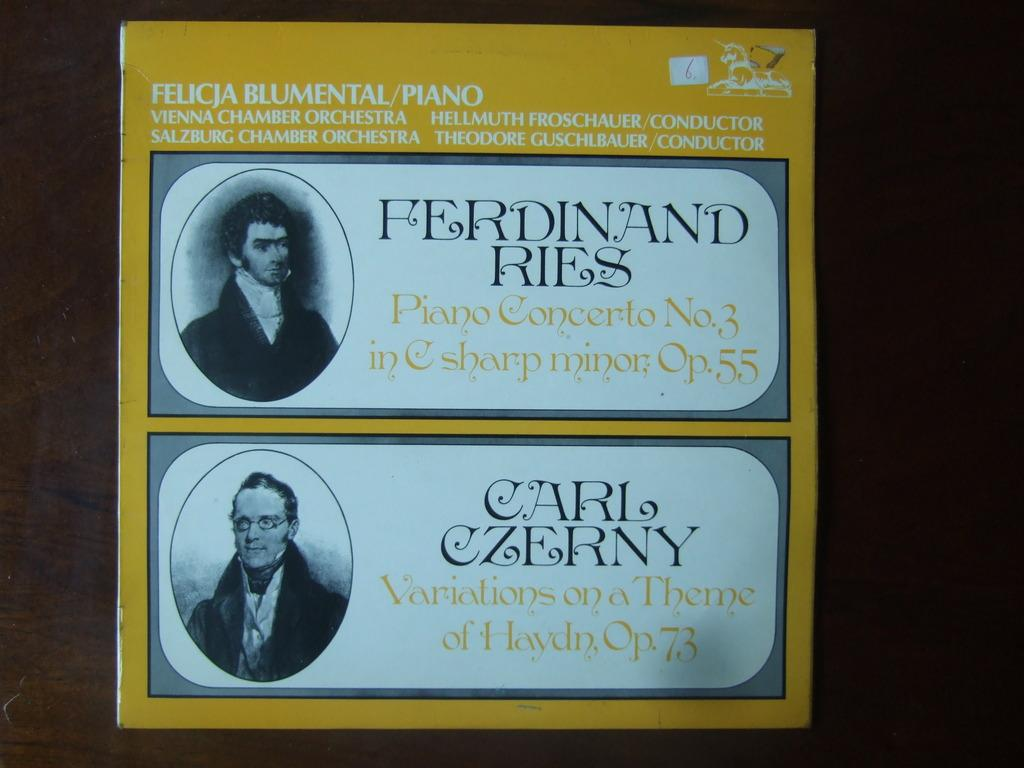What is featured in the image? There is a poster in the image. What can be seen on the poster? There are two people and a horse on the poster. What type of tin is being used to store the coal in the image? There is no tin or coal present in the image; it only features a poster with two people and a horse. 